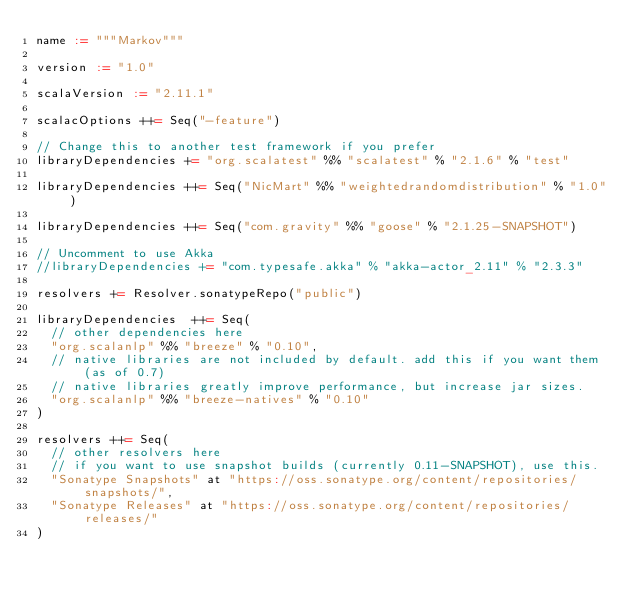<code> <loc_0><loc_0><loc_500><loc_500><_Scala_>name := """Markov"""

version := "1.0"

scalaVersion := "2.11.1"

scalacOptions ++= Seq("-feature")

// Change this to another test framework if you prefer
libraryDependencies += "org.scalatest" %% "scalatest" % "2.1.6" % "test"

libraryDependencies ++= Seq("NicMart" %% "weightedrandomdistribution" % "1.0")

libraryDependencies ++= Seq("com.gravity" %% "goose" % "2.1.25-SNAPSHOT")

// Uncomment to use Akka
//libraryDependencies += "com.typesafe.akka" % "akka-actor_2.11" % "2.3.3"

resolvers += Resolver.sonatypeRepo("public")

libraryDependencies  ++= Seq(
  // other dependencies here
  "org.scalanlp" %% "breeze" % "0.10",
  // native libraries are not included by default. add this if you want them (as of 0.7)
  // native libraries greatly improve performance, but increase jar sizes.
  "org.scalanlp" %% "breeze-natives" % "0.10"
)

resolvers ++= Seq(
  // other resolvers here
  // if you want to use snapshot builds (currently 0.11-SNAPSHOT), use this.
  "Sonatype Snapshots" at "https://oss.sonatype.org/content/repositories/snapshots/",
  "Sonatype Releases" at "https://oss.sonatype.org/content/repositories/releases/"
)</code> 